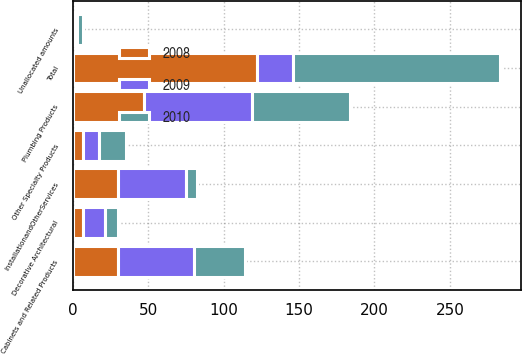Convert chart to OTSL. <chart><loc_0><loc_0><loc_500><loc_500><stacked_bar_chart><ecel><fcel>Cabinets and Related Products<fcel>Plumbing Products<fcel>InstallationandOtherServices<fcel>Decorative Architectural<fcel>Other Specialty Products<fcel>Unallocated amounts<fcel>Total<nl><fcel>2010<fcel>34<fcel>65<fcel>7<fcel>9<fcel>18<fcel>4<fcel>137<nl><fcel>2008<fcel>30<fcel>47<fcel>30<fcel>7<fcel>7<fcel>1<fcel>122<nl><fcel>2009<fcel>50<fcel>72<fcel>45<fcel>14<fcel>10<fcel>2<fcel>24<nl></chart> 